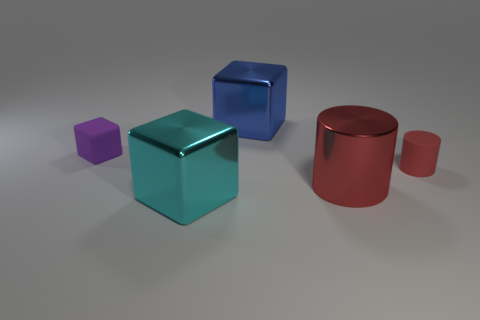Subtract all large shiny blocks. How many blocks are left? 1 Add 1 cyan cubes. How many objects exist? 6 Subtract all blue cubes. How many cubes are left? 2 Subtract all blocks. How many objects are left? 2 Subtract all blue spheres. How many purple blocks are left? 1 Subtract all large blue metallic cylinders. Subtract all small rubber blocks. How many objects are left? 4 Add 1 blue blocks. How many blue blocks are left? 2 Add 4 tiny red objects. How many tiny red objects exist? 5 Subtract 0 yellow cylinders. How many objects are left? 5 Subtract 2 cylinders. How many cylinders are left? 0 